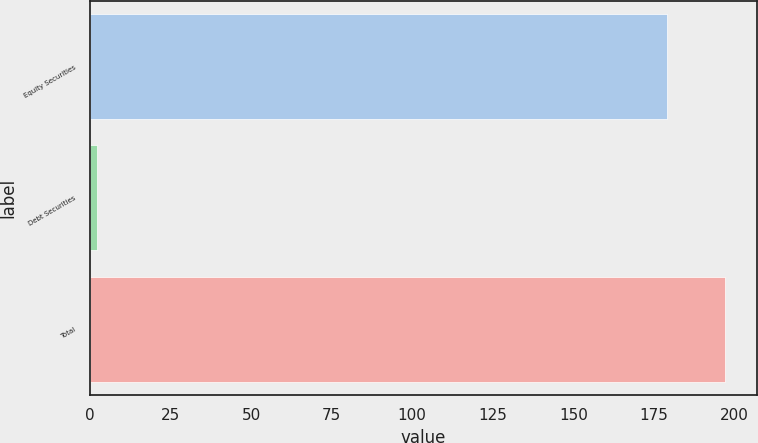Convert chart to OTSL. <chart><loc_0><loc_0><loc_500><loc_500><bar_chart><fcel>Equity Securities<fcel>Debt Securities<fcel>Total<nl><fcel>179.2<fcel>2.2<fcel>197.12<nl></chart> 